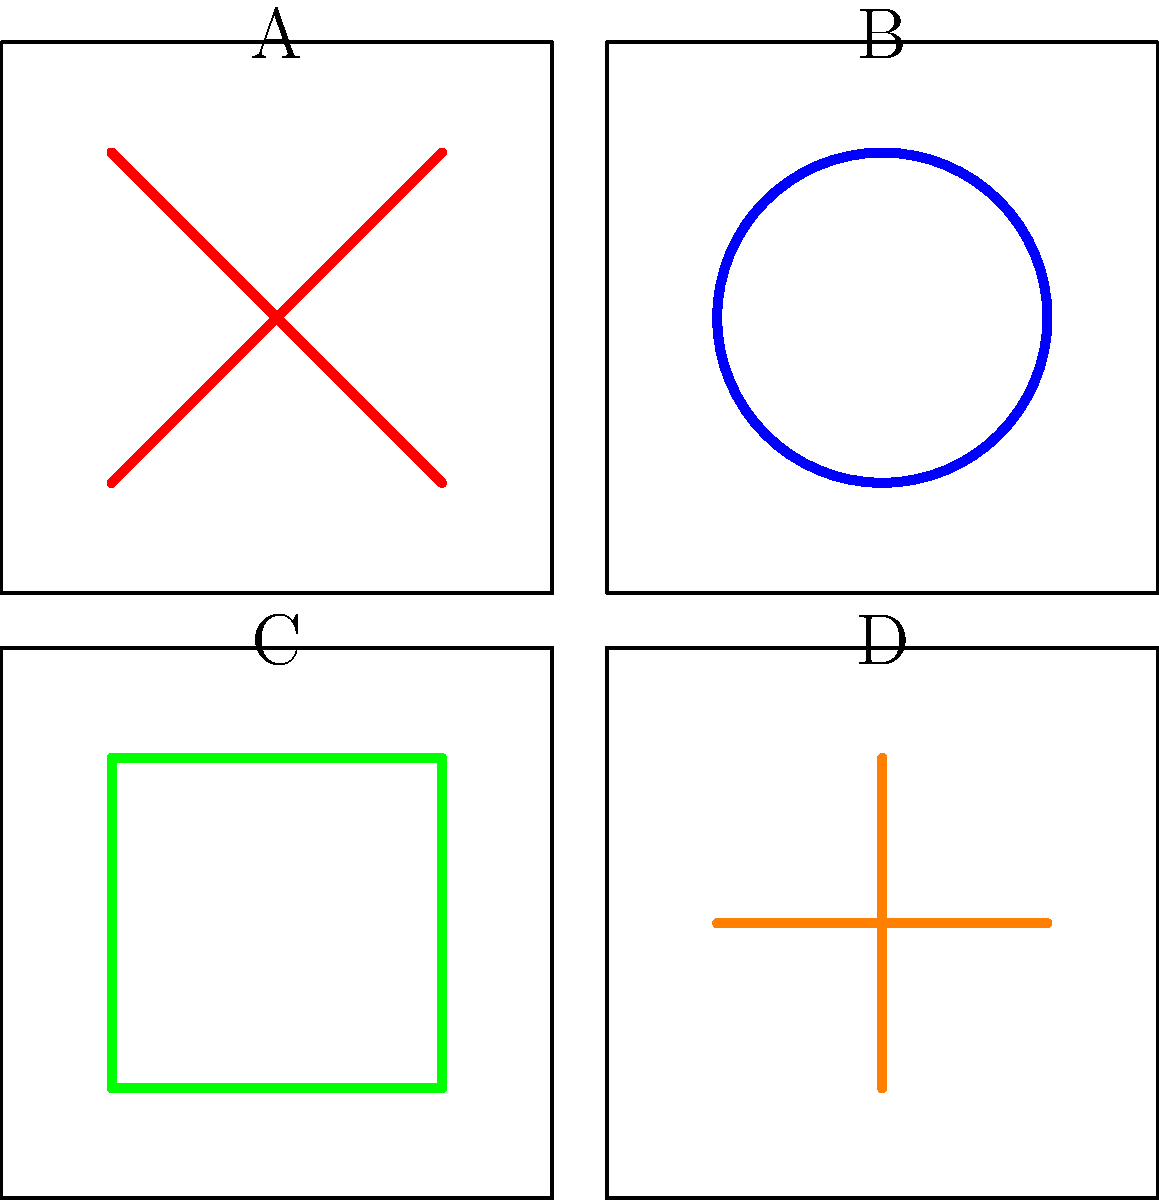As a computer science major interested in bringing comic book illustrations to life through technology, identify which of the simplified illustration styles (A, B, C, or D) most closely resembles the dynamic, energetic art style of Jack Kirby, known for his work on Marvel's Fantastic Four and X-Men. To identify Jack Kirby's art style, let's analyze each illustration:

1. Style A: Features bold, diagonal lines intersecting to create an "X" shape. This is characteristic of Kirby's dynamic, energetic style, often using strong, angular lines to convey motion and power.

2. Style B: Shows a circular, fluid line forming a closed shape. This is more reminiscent of Steve Ditko's psychedelic art style, famous for early Spider-Man comics.

3. Style C: Displays a simple square shape with strong, straight lines. This minimalist approach is more akin to Frank Miller's noir style, seen in works like Sin City.

4. Style D: Presents intersecting horizontal and vertical lines forming a cross. This structured, clean look is closer to Jim Lee's detailed, anatomically precise style.

Jack Kirby's art is known for its explosive energy, dynamic poses, and innovative page layouts. The intersecting diagonal lines in Style A best capture this sense of motion and power that Kirby often conveyed in his work.

As a computer science major interested in bringing comic illustrations to life, recognizing these distinct styles is crucial for accurately translating them into digital formats or animations while preserving their unique characteristics.
Answer: A 